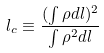<formula> <loc_0><loc_0><loc_500><loc_500>l _ { c } \equiv \frac { ( \int \rho d l ) ^ { 2 } } { \int \rho ^ { 2 } d l }</formula> 